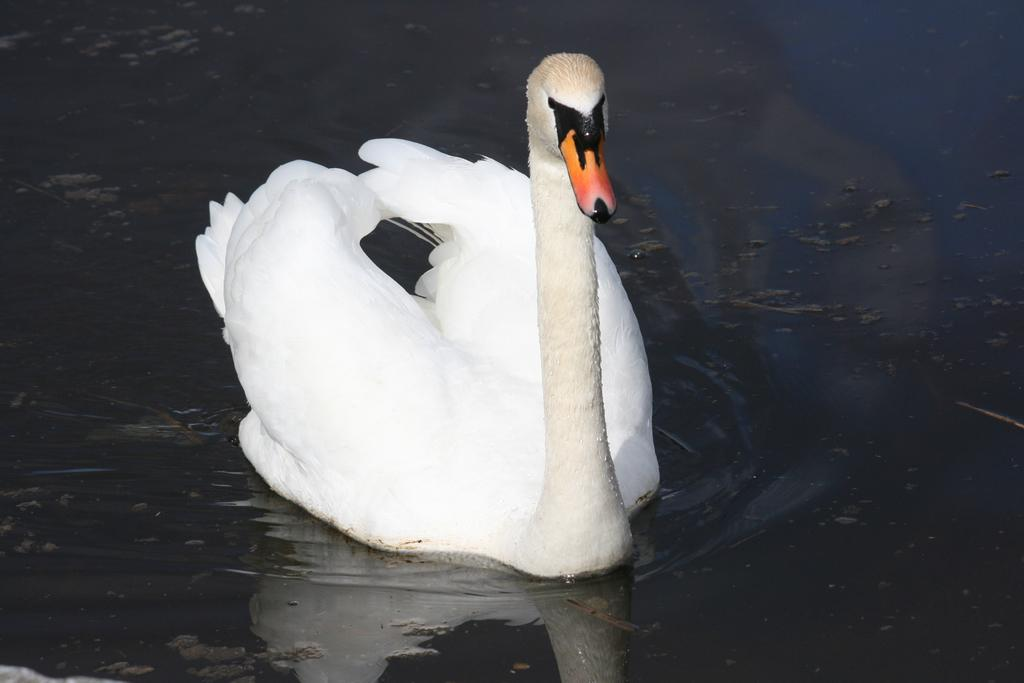What type of animal is in the image? There is a white swan in the image. Where is the swan located? The swan is on the water. What can be seen in the water besides the swan? There is a reflection of the swan and the sky in the water. What type of advertisement can be seen on the slope in the image? There is no advertisement or slope present in the image; it features a white swan on the water with reflections. 